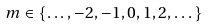Convert formula to latex. <formula><loc_0><loc_0><loc_500><loc_500>m \in \{ \dots , - 2 , - 1 , 0 , 1 , 2 , \dots \}</formula> 